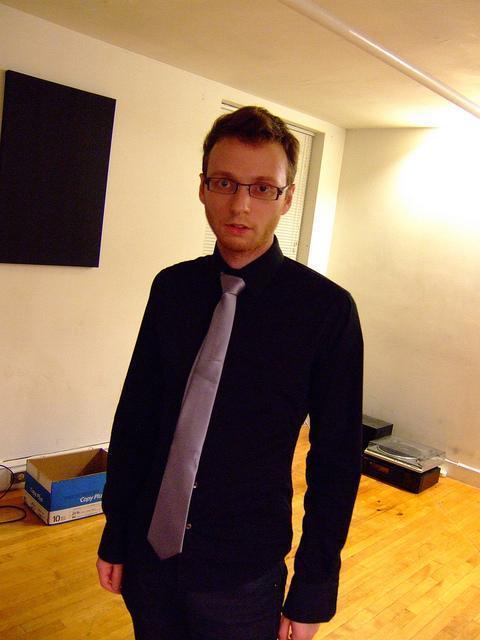What might explain the lack of furniture here?
Select the accurate response from the four choices given to answer the question.
Options: Pathological illness, he's moving, poverty, robbery. He's moving. 